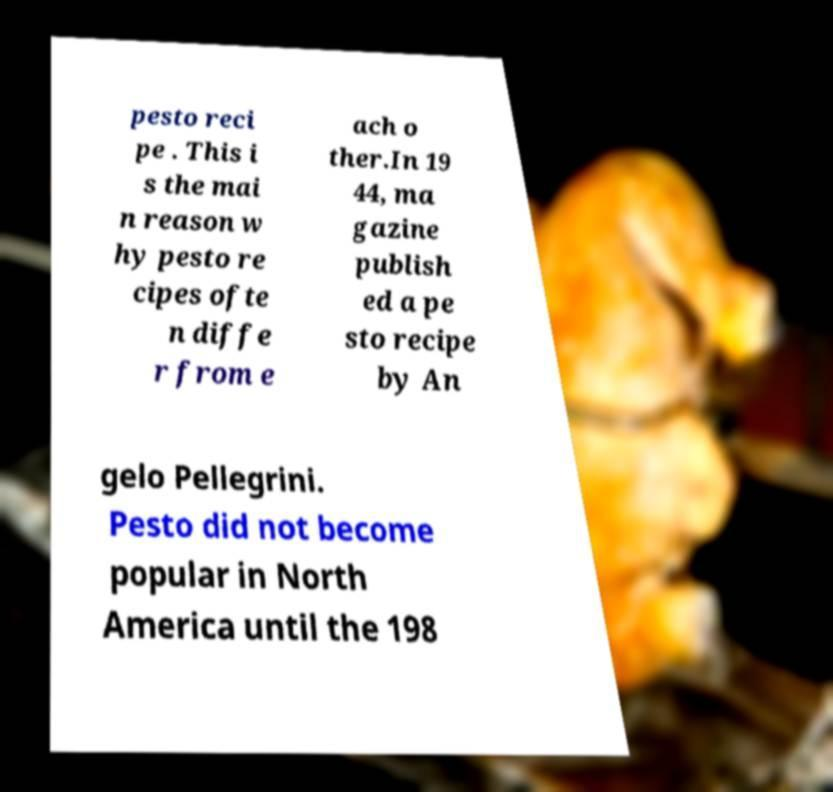For documentation purposes, I need the text within this image transcribed. Could you provide that? pesto reci pe . This i s the mai n reason w hy pesto re cipes ofte n diffe r from e ach o ther.In 19 44, ma gazine publish ed a pe sto recipe by An gelo Pellegrini. Pesto did not become popular in North America until the 198 